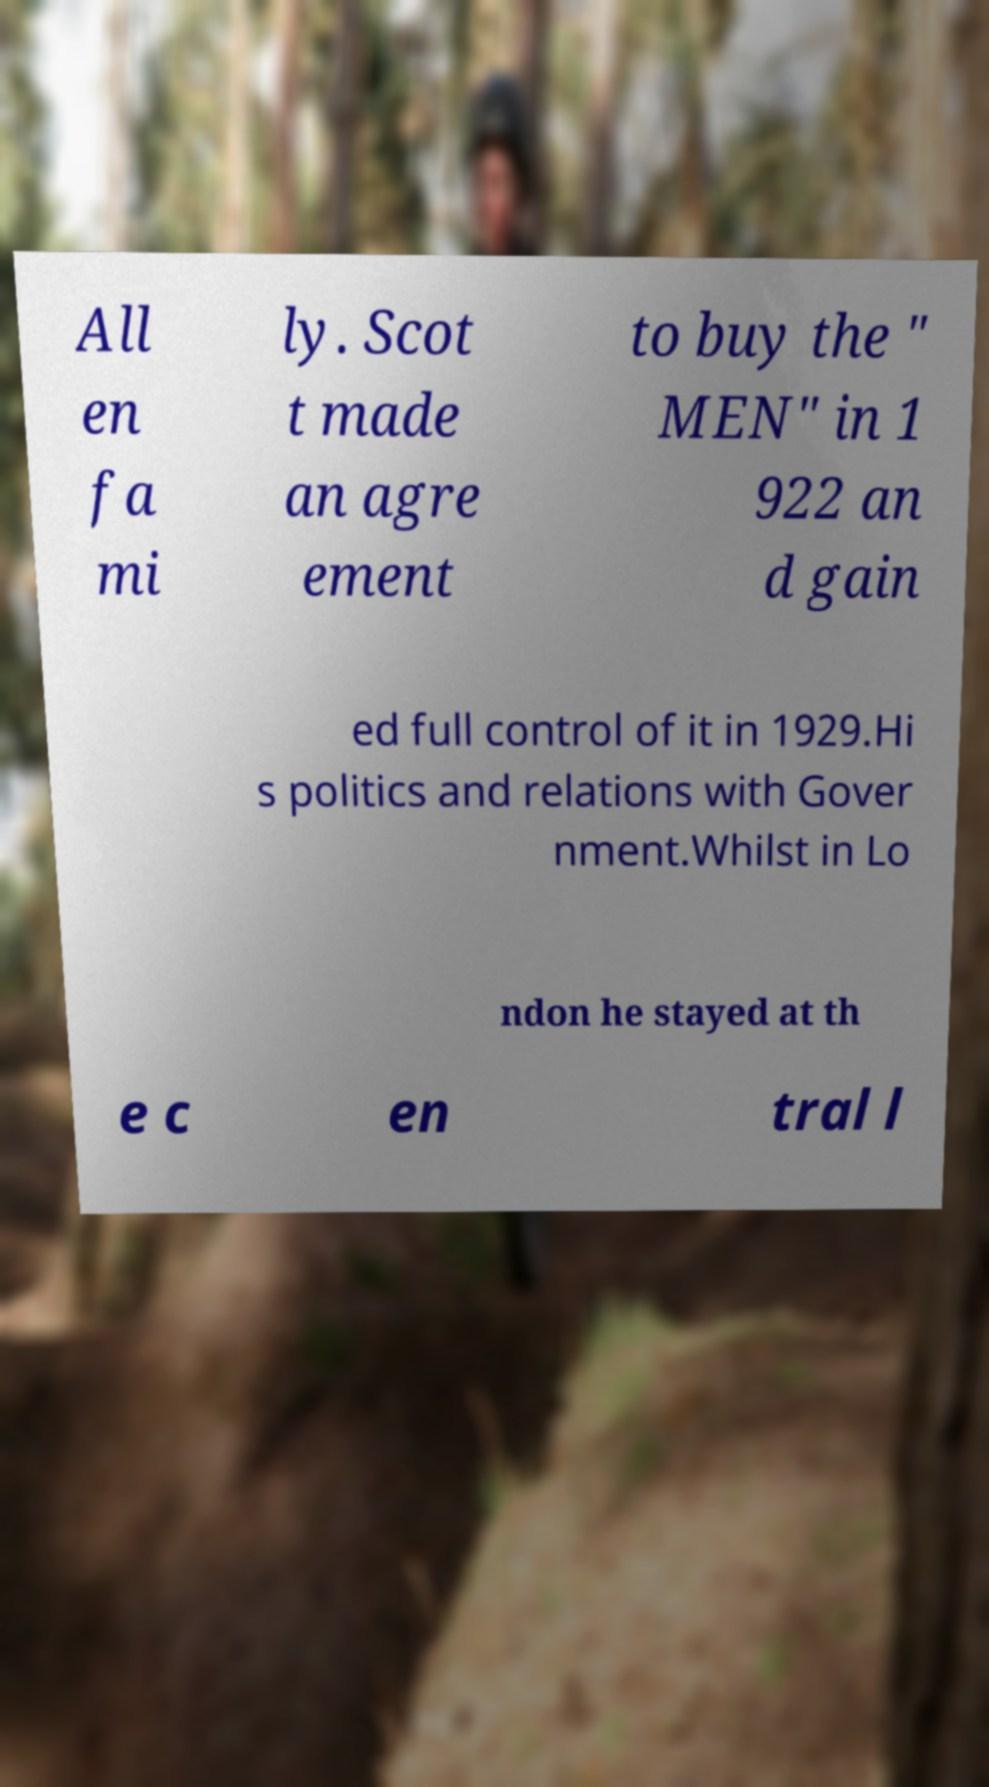Please read and relay the text visible in this image. What does it say? All en fa mi ly. Scot t made an agre ement to buy the " MEN" in 1 922 an d gain ed full control of it in 1929.Hi s politics and relations with Gover nment.Whilst in Lo ndon he stayed at th e c en tral l 